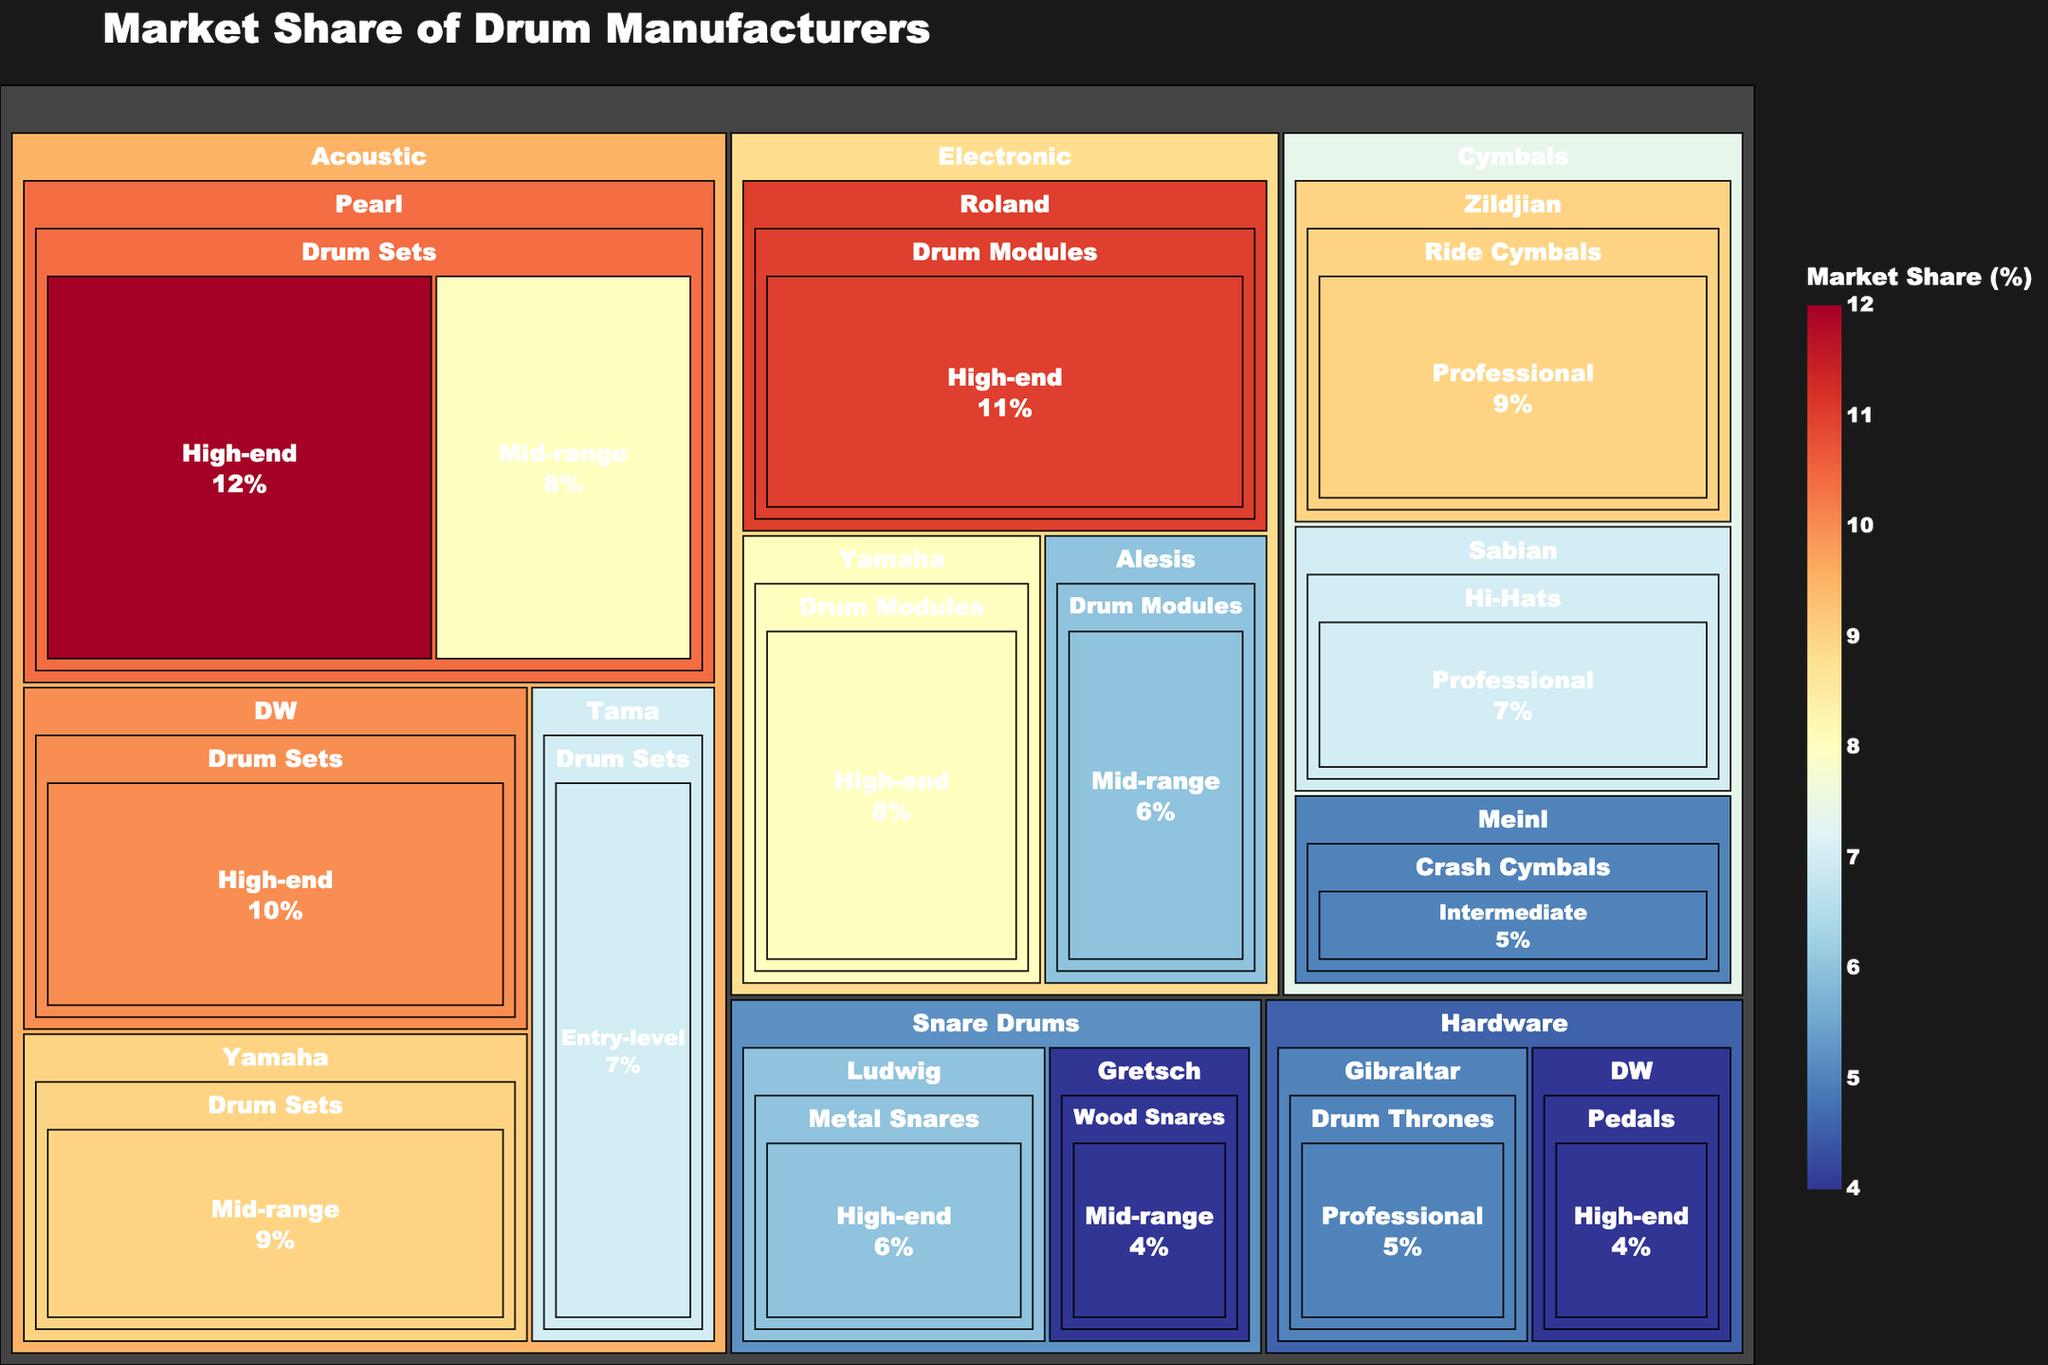What is the title of the treemap? The title is typically displayed at the top of the treemap. By reading the top of the figure, you can observe that the title is provided.
Answer: Market Share of Drum Manufacturers Which manufacturer has the highest market share in the category "Acoustic" and the product type "Drum Sets"? First, locate the "Acoustic" category, then identify the "Drum Sets" product type. Look at the market share values to find the highest one.
Answer: Pearl (High-end, 12%) How many product types are included under the "Electronic" category? Locate the "Electronic" category in the treemap and count the unique product types listed.
Answer: 1 (Drum Modules) Which price range has the highest market share for Ludwig's snare drums? Navigate to the "Snare Drums" category and find Ludwig. Check the market share values of different price ranges for Ludwig's snare drums.
Answer: High-end (6%) Compare the market share of high-end drum modules by Roland to mid-range drum modules by Alesis. Which one is higher? Locate the "Electronic" category, then compare the market share of high-end drum modules by Roland and mid-range drum modules by Alesis.
Answer: Roland (11%) What is the total market share of all "Professional" cymbals combined? Identify all "Professional" cymbals and add their market shares together. Two manufacturers fit this category: Zildjian (Ride Cymbals, 9) and Sabian (Hi-Hats, 7). The total is 9 + 7.
Answer: 16 Identify the category with the lowest aggregate market share and provide its value. Sum the market share values within each category and identify the lowest. Categories and their sums are: Acoustic 46, Electronic 25, Cymbals 21, Snare Drums 10, Hardware 9. "Hardware" has the lowest sum.
Answer: Hardware (9) Which has a higher market share, entry-level drum sets by Tama or high-end wood snare drums by Gretsch? Locate the corresponding entries for Tama's entry-level drum sets and Gretsch's high-end wood snare drums, then compare their market values.
Answer: Tama (7%) What percentage of the market share do mid-range drum sets by Pearl and mid-range drum sets by Yamaha hold combined? Locate the market share for mid-range drum sets by Pearl (8) and Yamaha (9), then sum these values and provide the answer as a percentage.
Answer: 17 